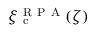Convert formula to latex. <formula><loc_0><loc_0><loc_500><loc_500>\xi _ { c } ^ { R P A } ( \zeta )</formula> 